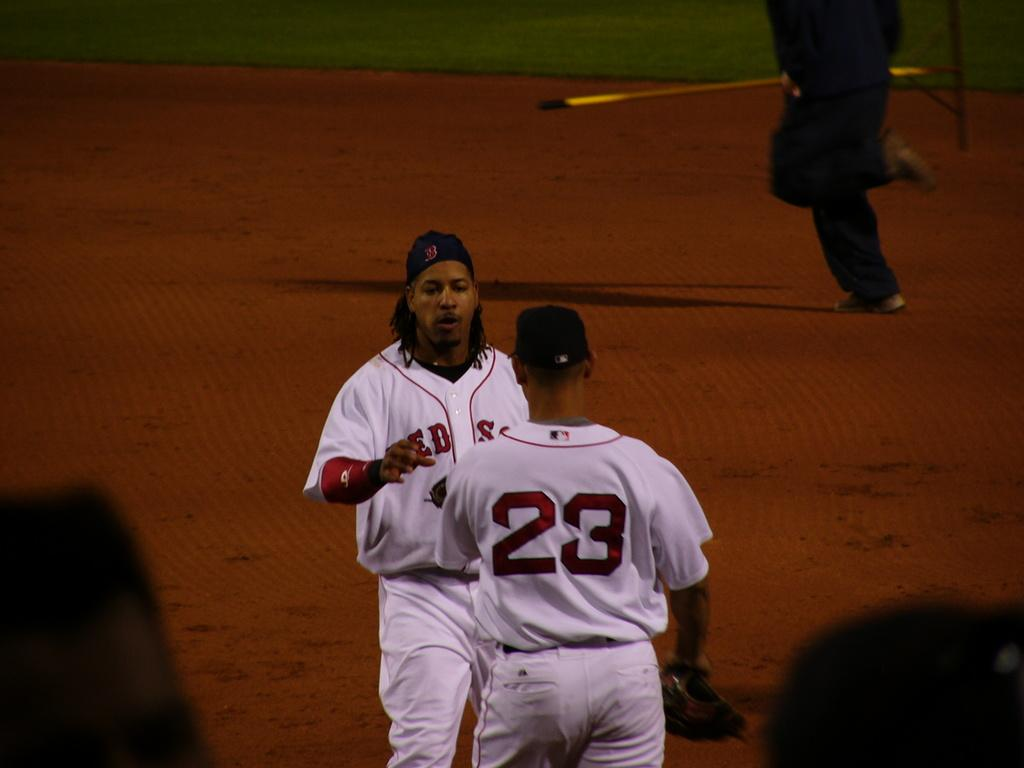<image>
Give a short and clear explanation of the subsequent image. two baseball players in white jerseys and one with 23 on the back 